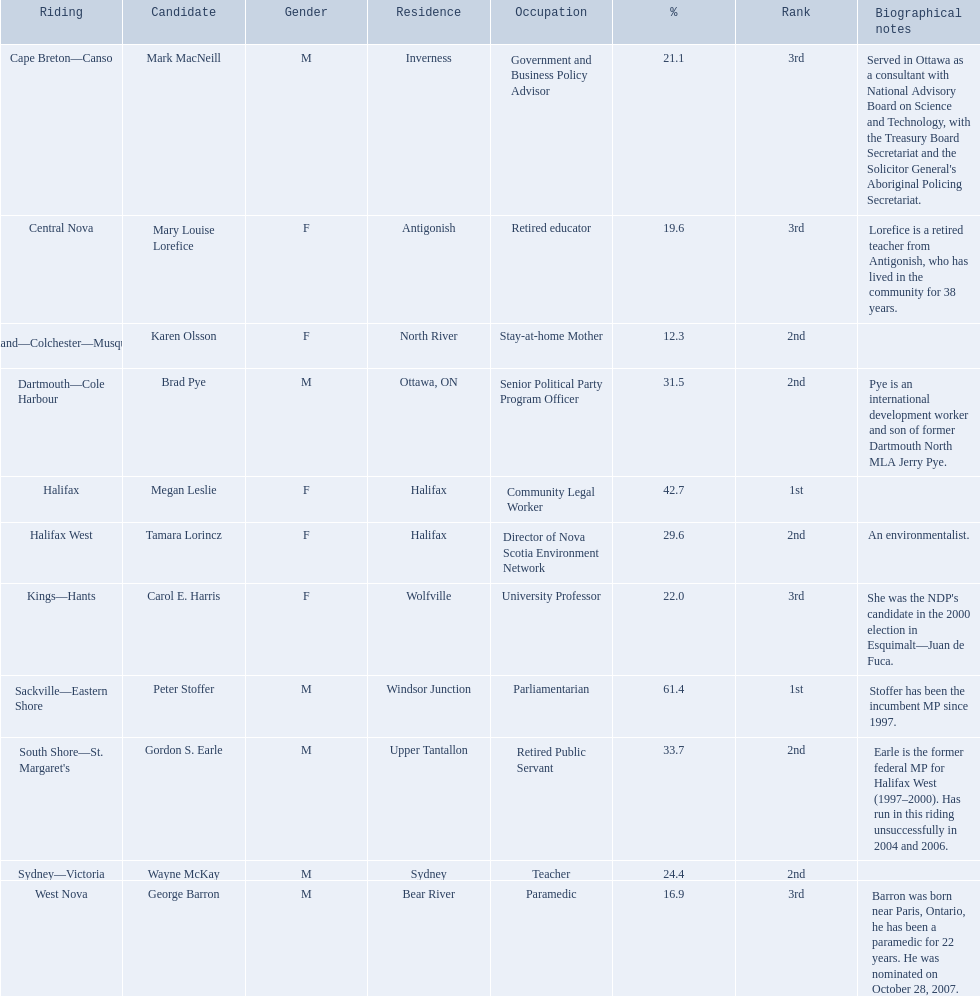How many votes did macneill receive? 7,660. How many votes did olsoon receive? 4,874. Between macneil and olsson, who received more votes? Mark MacNeill. 